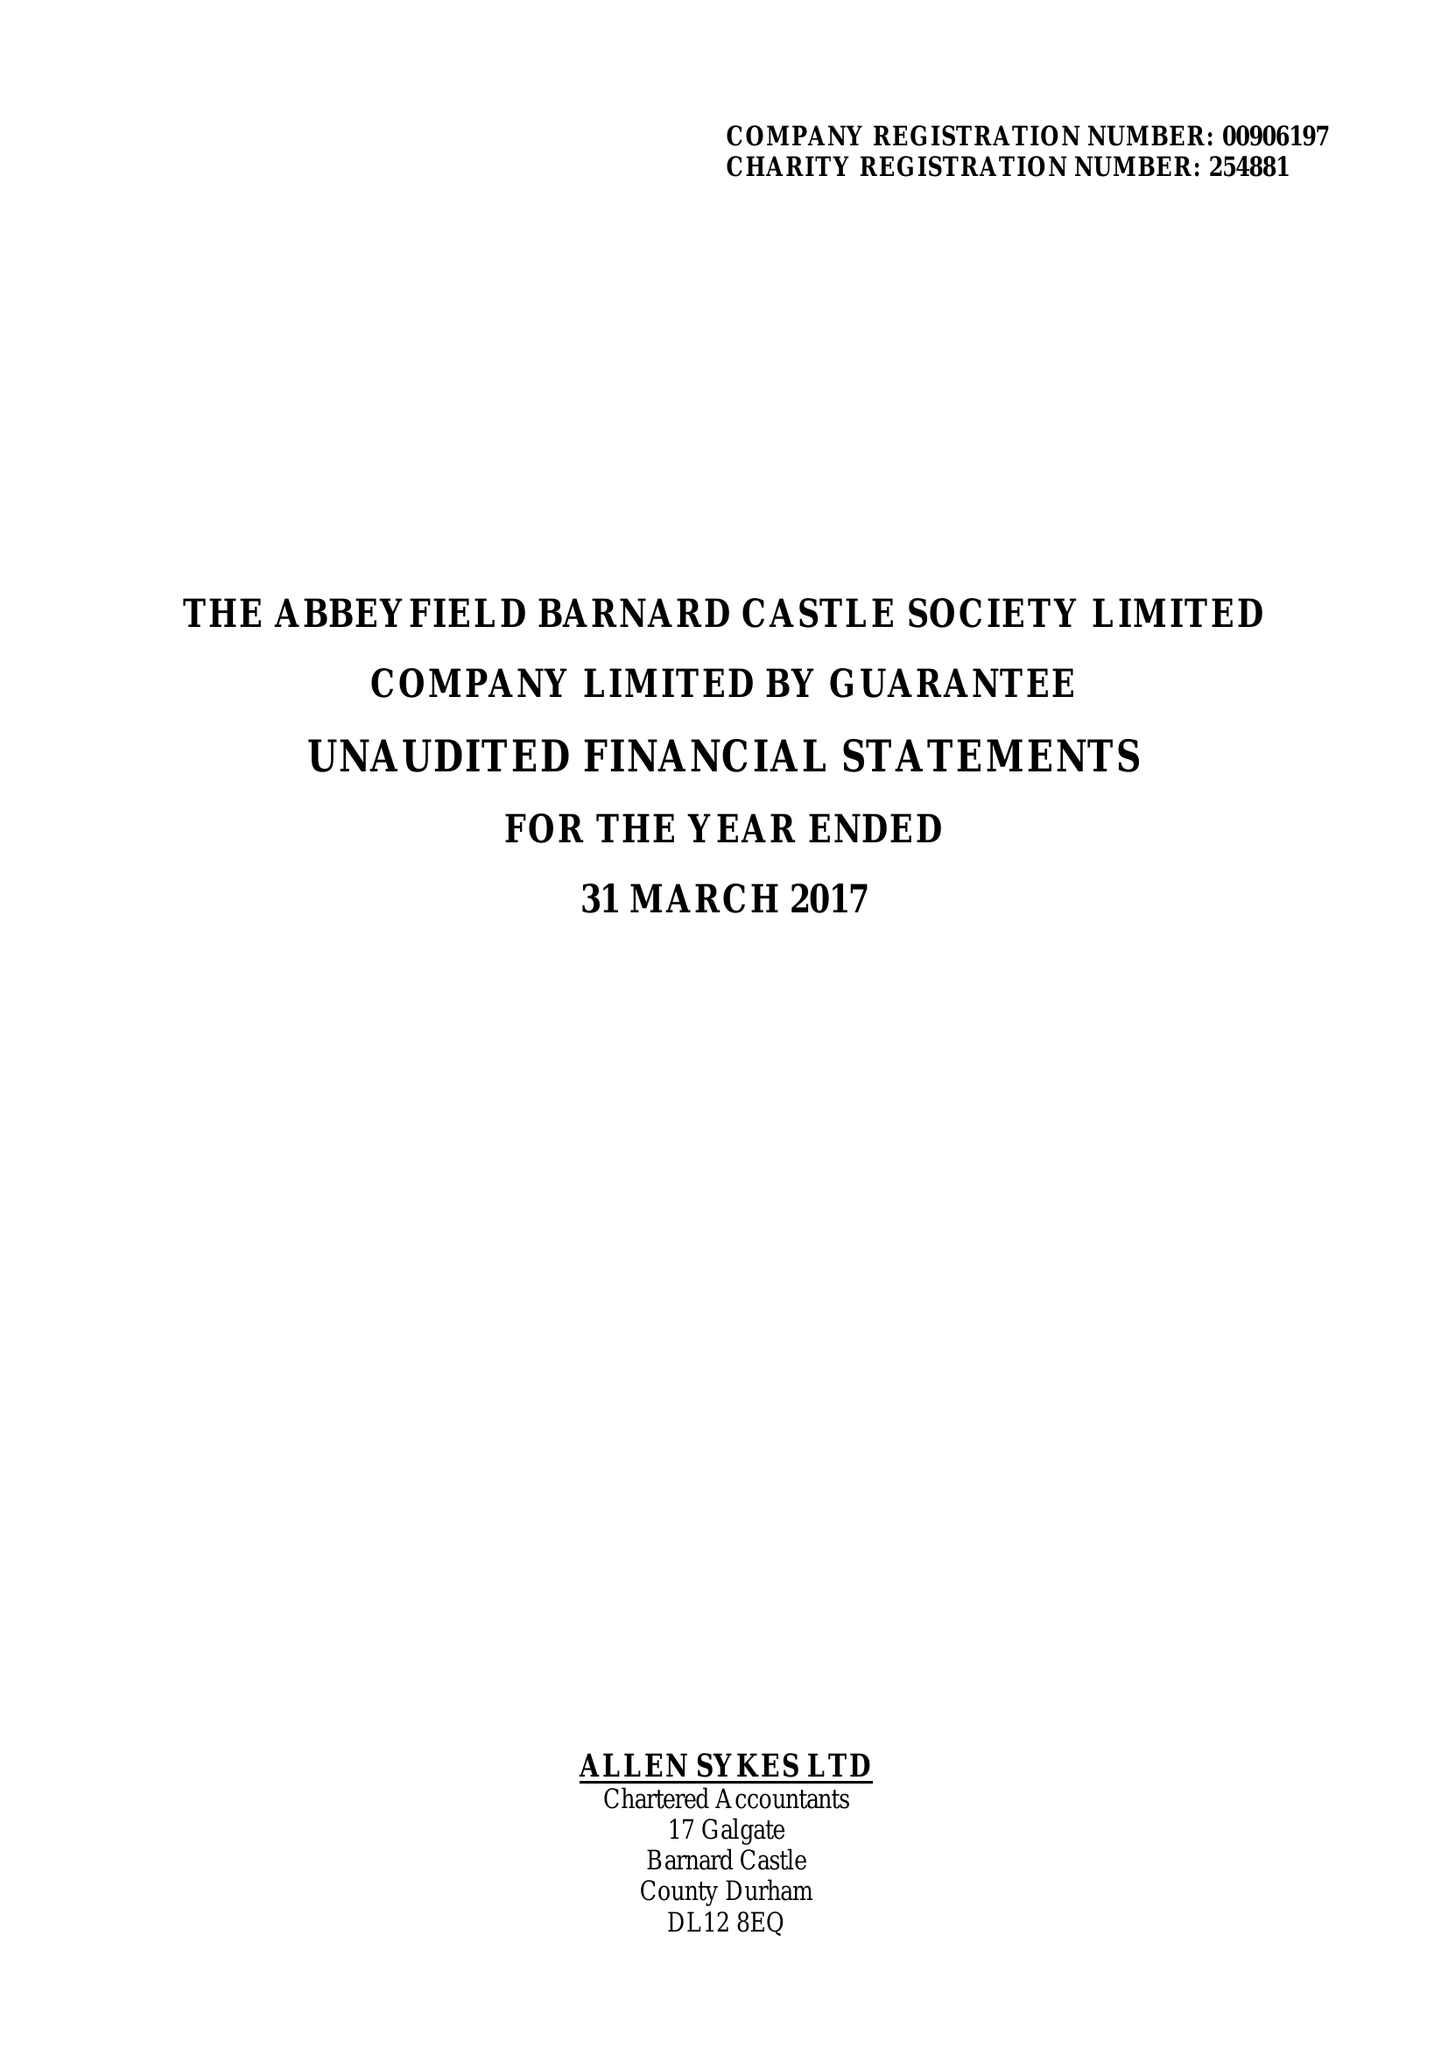What is the value for the address__post_town?
Answer the question using a single word or phrase. BARNARD CASTLE 